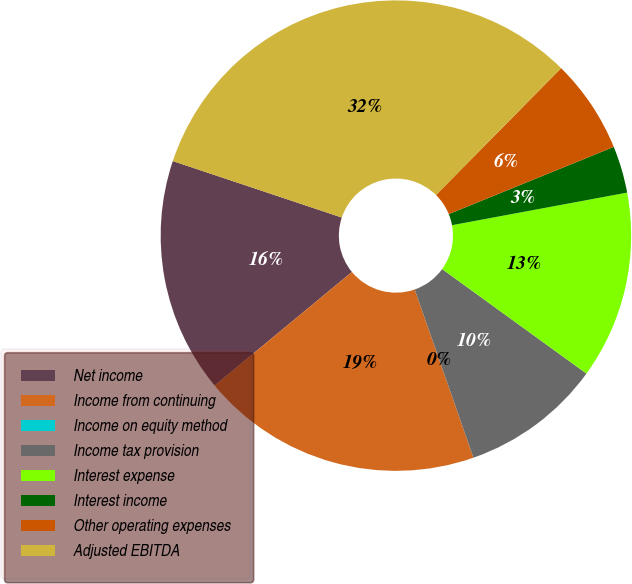<chart> <loc_0><loc_0><loc_500><loc_500><pie_chart><fcel>Net income<fcel>Income from continuing<fcel>Income on equity method<fcel>Income tax provision<fcel>Interest expense<fcel>Interest income<fcel>Other operating expenses<fcel>Adjusted EBITDA<nl><fcel>16.13%<fcel>19.35%<fcel>0.0%<fcel>9.68%<fcel>12.9%<fcel>3.23%<fcel>6.45%<fcel>32.26%<nl></chart> 